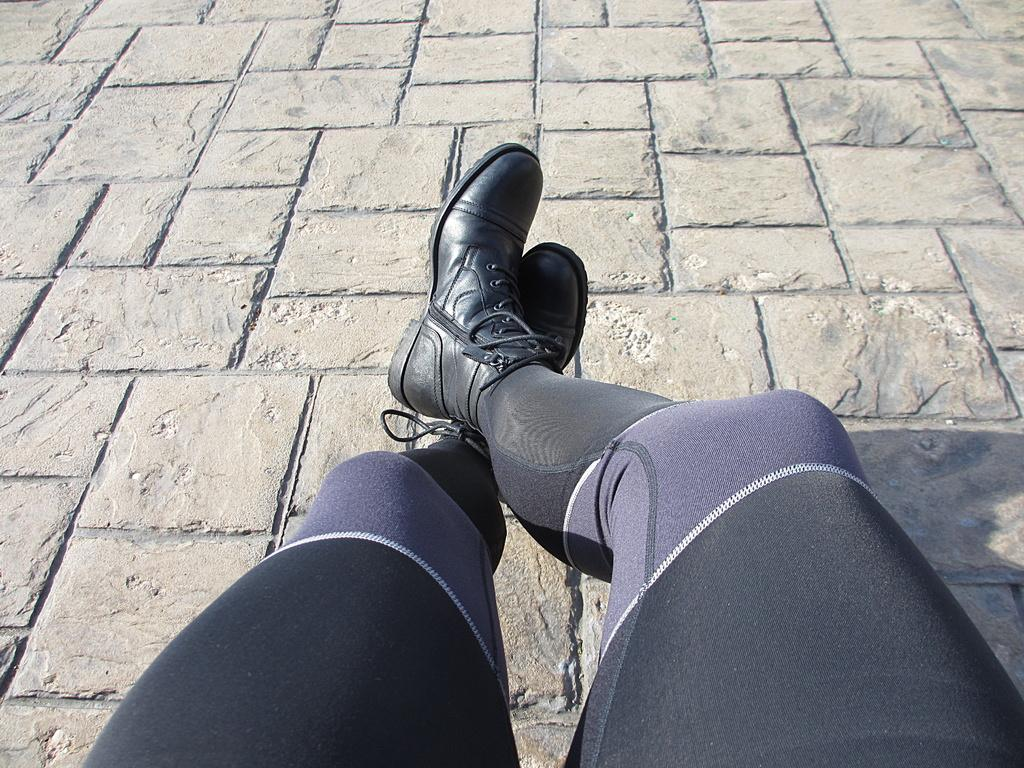What part of a person can be seen in the image? The image contains the legs of a person. What type of footwear is the person wearing? The person is wearing a black shoe. What surface is visible beneath the person's legs? There is a floor visible in the image. What type of skin condition is visible on the person's legs in the image? There is no indication of any skin condition visible on the person's legs in the image. What type of flock of birds can be seen flying in the image? There are no birds present in the image. 